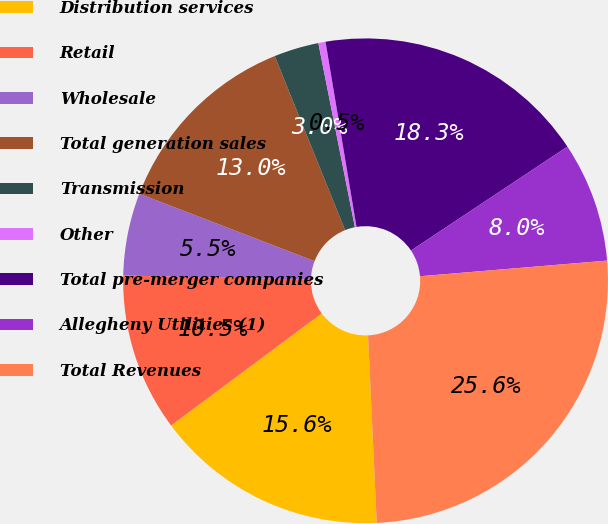Convert chart. <chart><loc_0><loc_0><loc_500><loc_500><pie_chart><fcel>Distribution services<fcel>Retail<fcel>Wholesale<fcel>Total generation sales<fcel>Transmission<fcel>Other<fcel>Total pre-merger companies<fcel>Allegheny Utilities (1)<fcel>Total Revenues<nl><fcel>15.55%<fcel>10.53%<fcel>5.5%<fcel>13.04%<fcel>2.99%<fcel>0.48%<fcel>18.3%<fcel>8.01%<fcel>25.59%<nl></chart> 